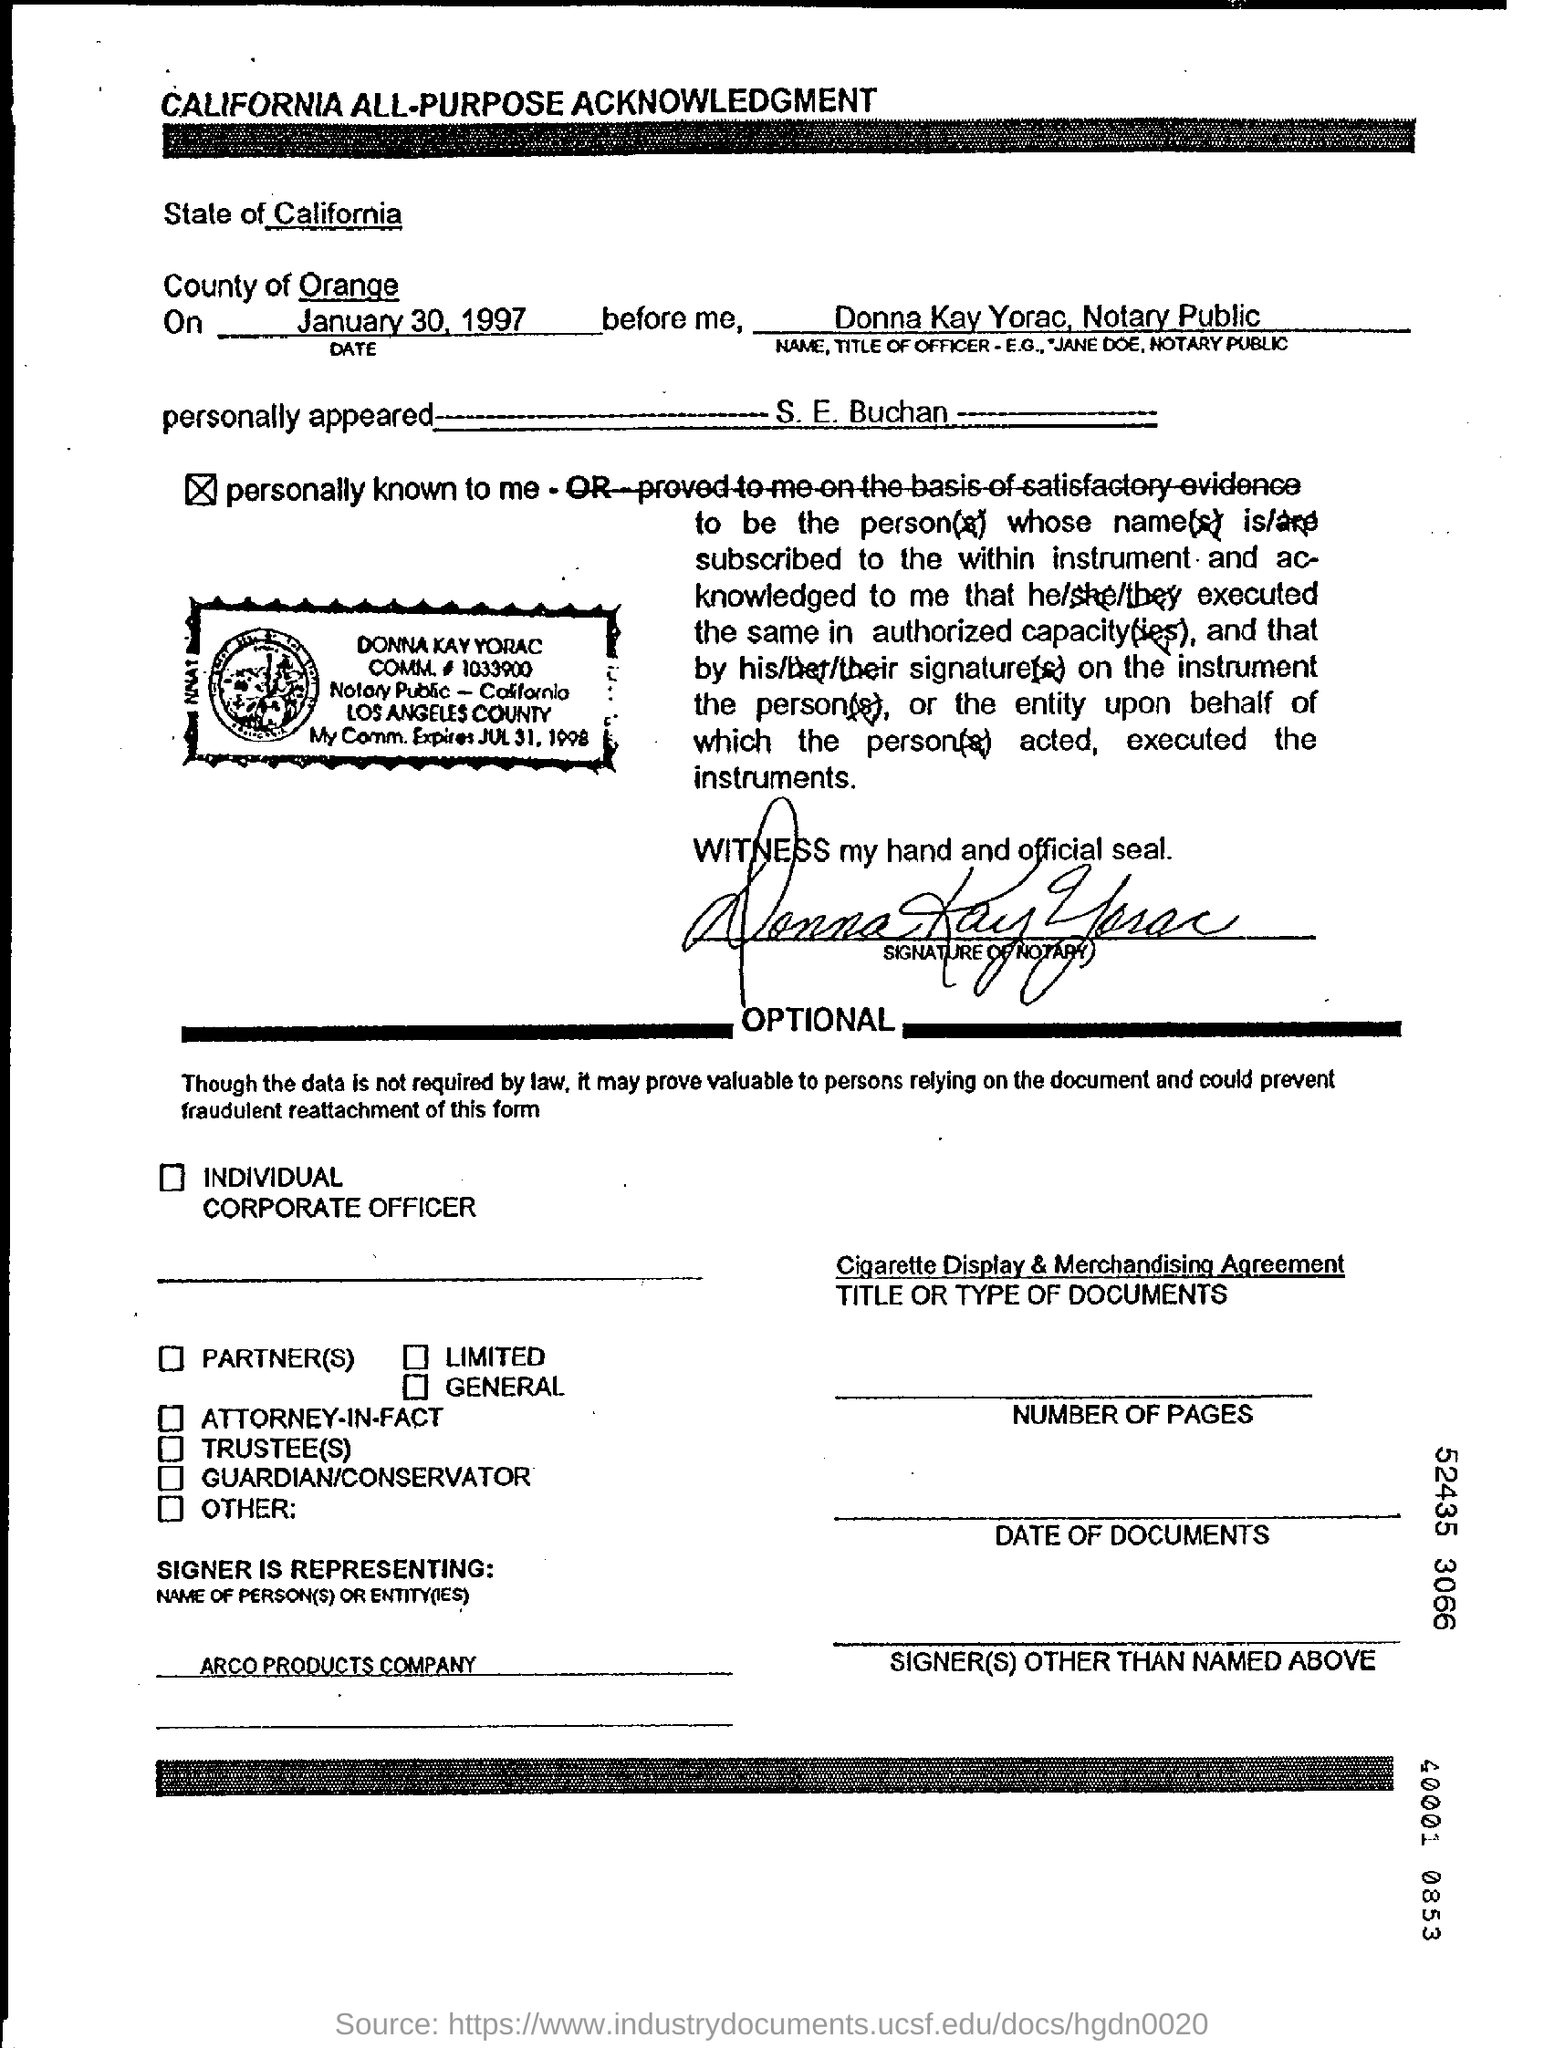What is the name of the officer ?
Make the answer very short. Donna kay yorac. What is the title of officer ?
Your response must be concise. Notary Public. Which state is mentioned ?
Provide a succinct answer. California. 